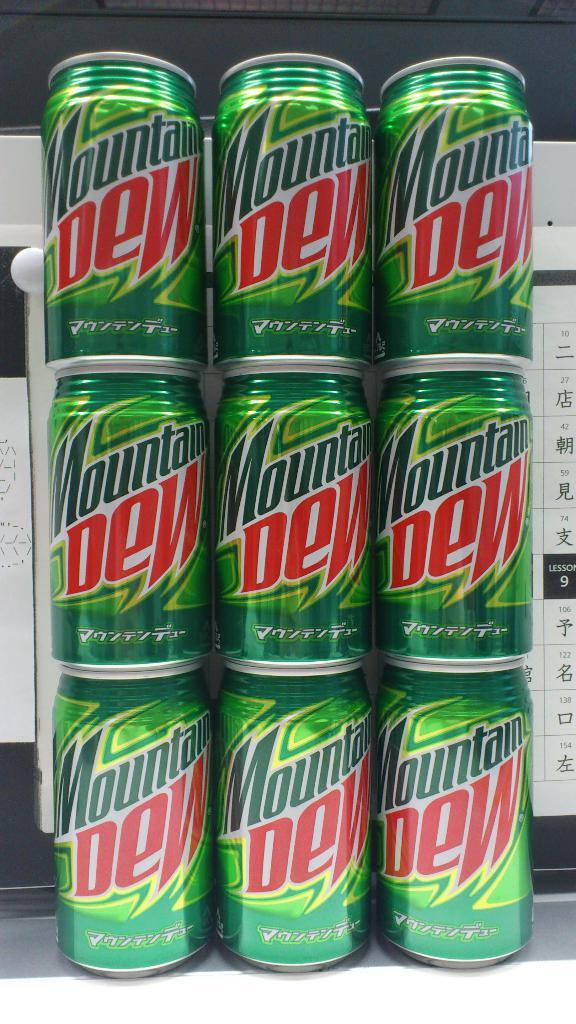<image>
Give a short and clear explanation of the subsequent image. A stack of nine Mountain Dew cans the in each row. 